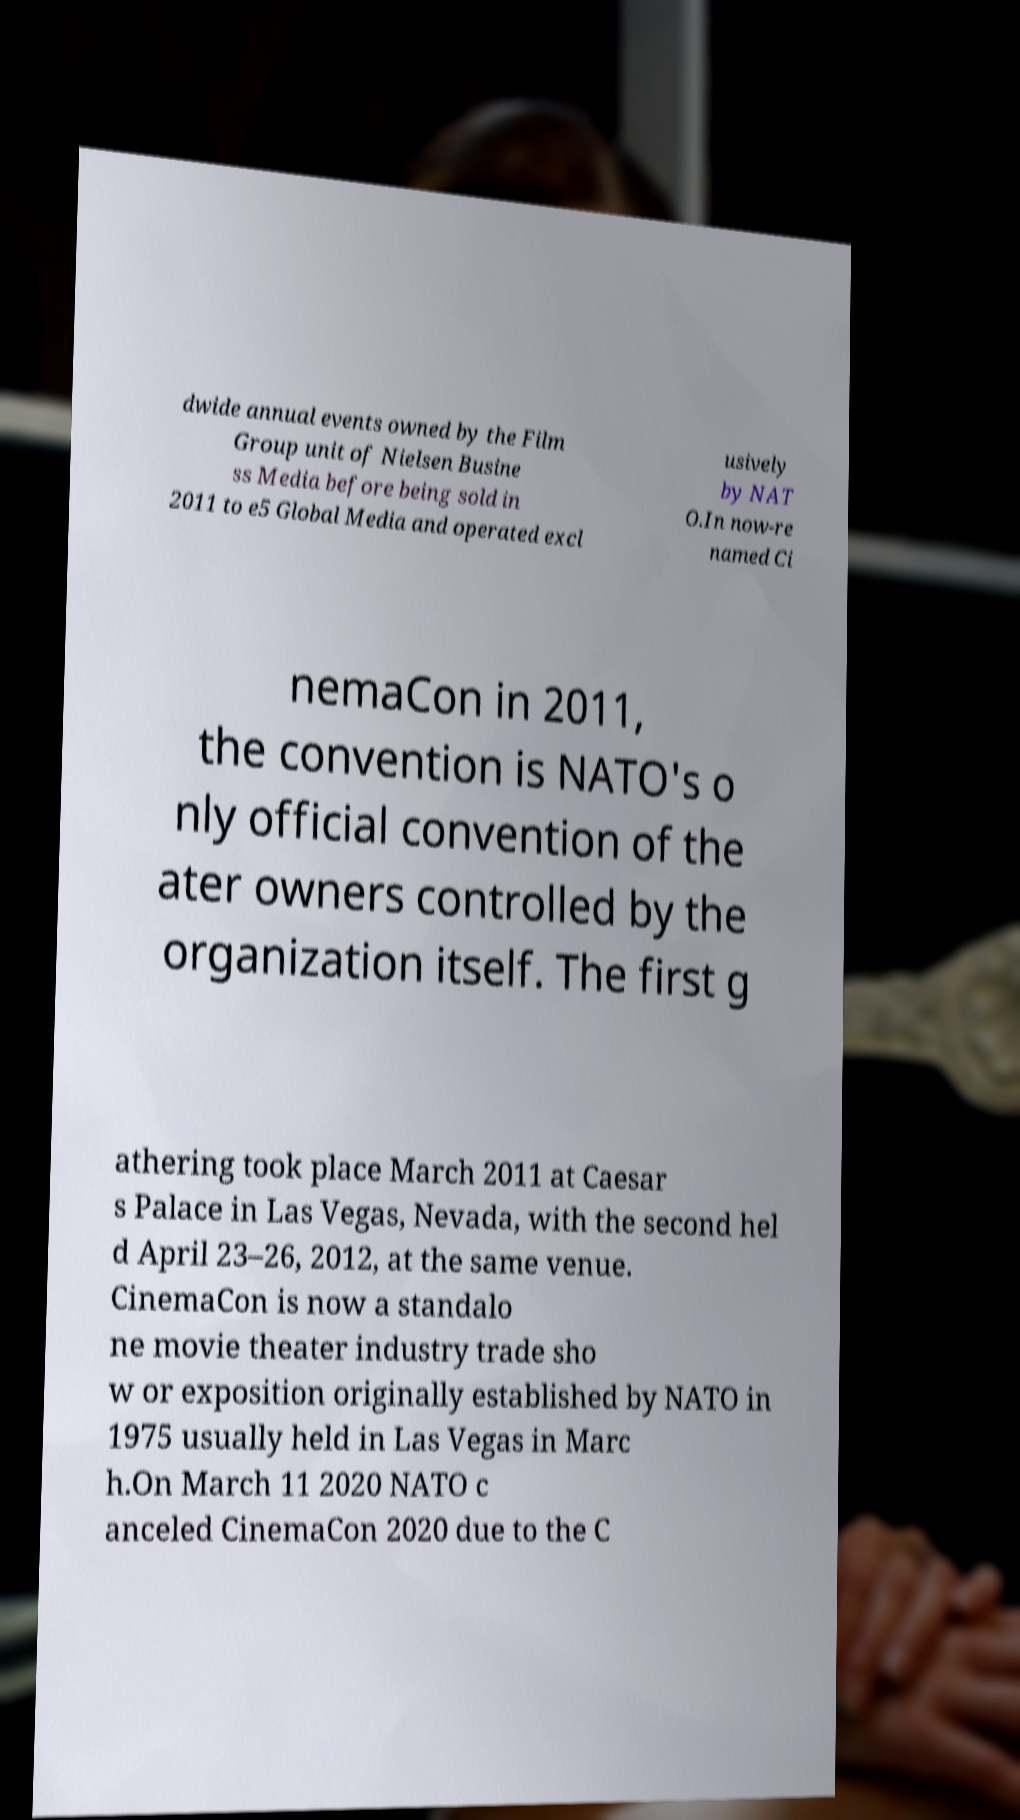Could you extract and type out the text from this image? dwide annual events owned by the Film Group unit of Nielsen Busine ss Media before being sold in 2011 to e5 Global Media and operated excl usively by NAT O.In now-re named Ci nemaCon in 2011, the convention is NATO's o nly official convention of the ater owners controlled by the organization itself. The first g athering took place March 2011 at Caesar s Palace in Las Vegas, Nevada, with the second hel d April 23–26, 2012, at the same venue. CinemaCon is now a standalo ne movie theater industry trade sho w or exposition originally established by NATO in 1975 usually held in Las Vegas in Marc h.On March 11 2020 NATO c anceled CinemaCon 2020 due to the C 